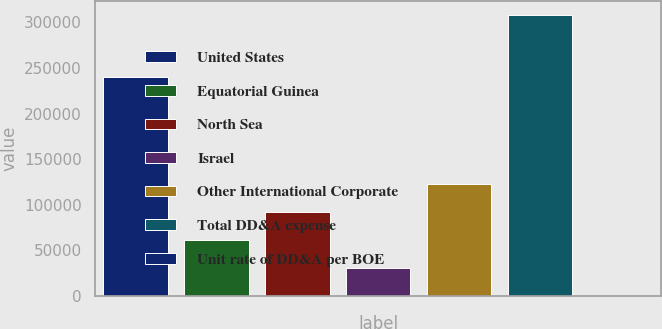Convert chart to OTSL. <chart><loc_0><loc_0><loc_500><loc_500><bar_chart><fcel>United States<fcel>Equatorial Guinea<fcel>North Sea<fcel>Israel<fcel>Other International Corporate<fcel>Total DD&A expense<fcel>Unit rate of DD&A per BOE<nl><fcel>240058<fcel>61627<fcel>92436.5<fcel>30817.5<fcel>123246<fcel>308103<fcel>7.97<nl></chart> 